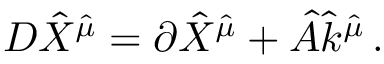Convert formula to latex. <formula><loc_0><loc_0><loc_500><loc_500>D { \hat { X } } ^ { { \hat { \mu } } } = \partial { \hat { X } } ^ { { \hat { \mu } } } + { \hat { A } } { \hat { k } } ^ { { \hat { \mu } } } \, .</formula> 